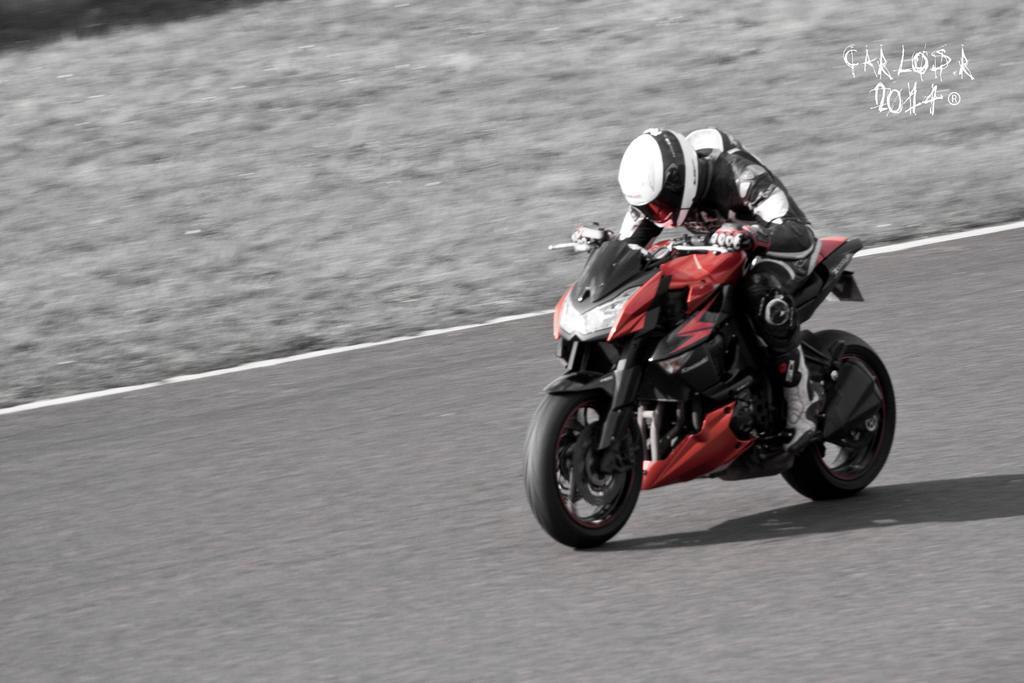How would you summarize this image in a sentence or two? At the top right corner of the image we can see a water mark. Here we can see a man wearing a helmet, gloves and riding a motor bike on the road. 